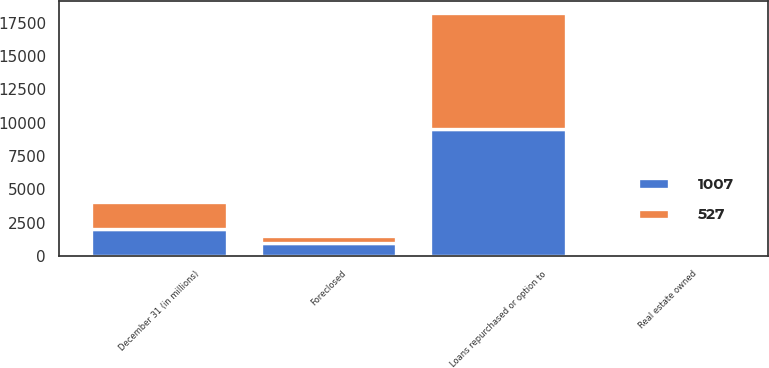<chart> <loc_0><loc_0><loc_500><loc_500><stacked_bar_chart><ecel><fcel>December 31 (in millions)<fcel>Loans repurchased or option to<fcel>Real estate owned<fcel>Foreclosed<nl><fcel>527<fcel>2017<fcel>8629<fcel>95<fcel>527<nl><fcel>1007<fcel>2016<fcel>9556<fcel>142<fcel>1007<nl></chart> 